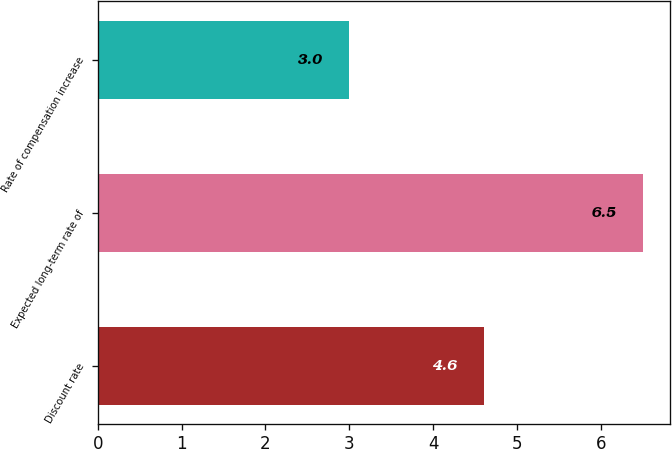Convert chart. <chart><loc_0><loc_0><loc_500><loc_500><bar_chart><fcel>Discount rate<fcel>Expected long-term rate of<fcel>Rate of compensation increase<nl><fcel>4.6<fcel>6.5<fcel>3<nl></chart> 